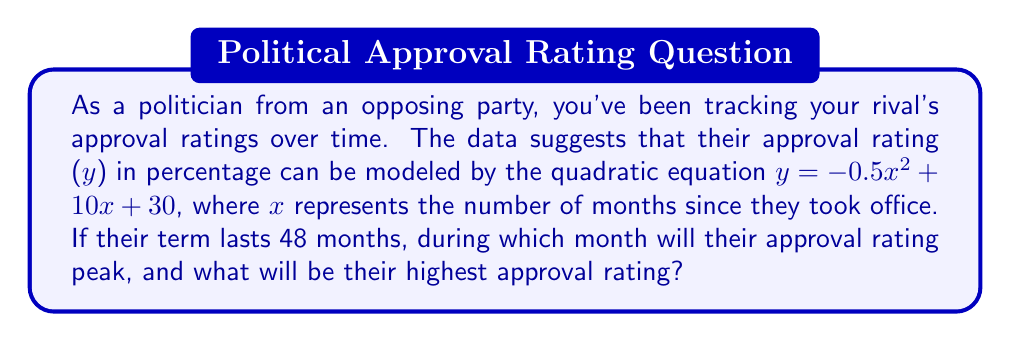Help me with this question. To solve this problem, we need to follow these steps:

1) The quadratic equation given is in the form $y = ax^2 + bx + c$, where:
   $a = -0.5$, $b = 10$, and $c = 30$

2) For a quadratic function, the x-coordinate of the vertex represents the point where y reaches its maximum (if $a < 0$) or minimum (if $a > 0$).

3) The formula for the x-coordinate of the vertex is: $x = -\frac{b}{2a}$

4) Substituting our values:
   $x = -\frac{10}{2(-0.5)} = -\frac{10}{-1} = 10$

5) This means the approval rating will peak at 10 months.

6) To find the highest approval rating, we need to calculate y when x = 10:

   $y = -0.5(10)^2 + 10(10) + 30$
   $= -0.5(100) + 100 + 30$
   $= -50 + 100 + 30$
   $= 80$

Therefore, the approval rating will peak at 80%.

[asy]
import graph;
size(200,200);
real f(real x) {return -0.5*x^2 + 10*x + 30;}
draw(graph(f,0,20),blue);
dot((10,80),red);
xaxis("Months",0,20,arrow=Arrow);
yaxis("Approval Rating (%)",0,100,arrow=Arrow);
label("(10,80)",(10,80),NE);
[/asy]
Answer: The approval rating will peak at 10 months with a maximum value of 80%. 